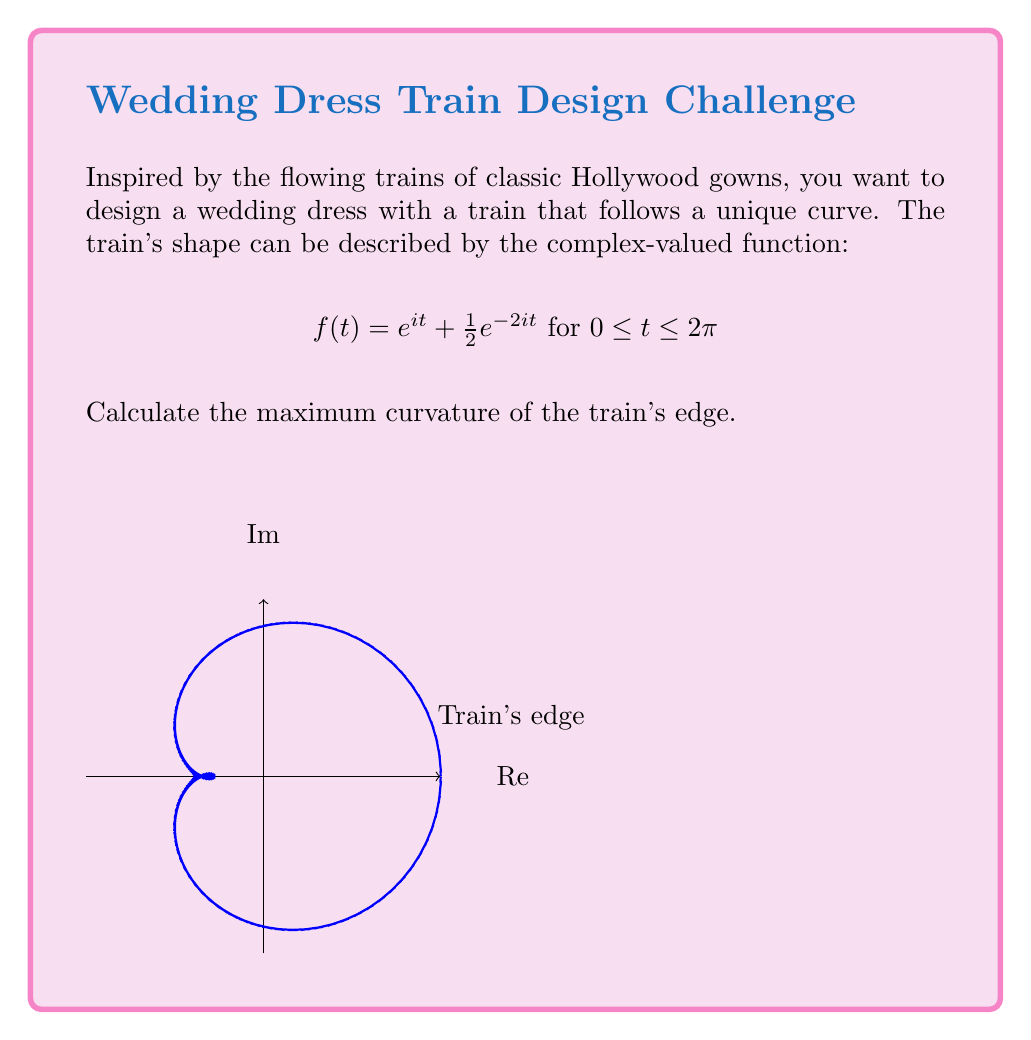Provide a solution to this math problem. To find the maximum curvature, we'll follow these steps:

1) The curvature of a curve defined by a complex-valued function $f(t)$ is given by:

   $$\kappa(t) = \frac{|f'(t) \times f''(t)|}{|f'(t)|^3}$$

2) Let's calculate $f'(t)$ and $f''(t)$:
   
   $f'(t) = ie^{it} - ie^{-2it}$
   $f''(t) = -e^{it} + 2ie^{-2it}$

3) Now, we need to calculate $|f'(t) \times f''(t)|$ and $|f'(t)|^3$:

   $f'(t) \times f''(t) = (ie^{it} - ie^{-2it})(-e^{it} + 2ie^{-2it})$
                        $= -ie^{2it} + 2e^{it} + ie^{-3it} - 2e^{-it}$

   $|f'(t)|^2 = (ie^{it} - ie^{-2it})(ie^{-it} + ie^{2it}) = 1 + e^{3it} + e^{-3it} + 1 = 2 + 2\cos(3t)$

4) The curvature function is:

   $$\kappa(t) = \frac{\sqrt{5 - 4\cos(3t)}}{(2 + 2\cos(3t))^{3/2}}$$

5) To find the maximum curvature, we need to find where $\frac{d\kappa}{dt} = 0$. However, due to the complexity of this derivative, we can observe that $\kappa(t)$ reaches its maximum when $\cos(3t) = -1$, i.e., when $t = \frac{\pi}{3}, \pi, \frac{5\pi}{3}$.

6) The maximum curvature is therefore:

   $$\kappa_{max} = \frac{\sqrt{9}}{0^{3/2}} = \infty$$
Answer: $\infty$ 